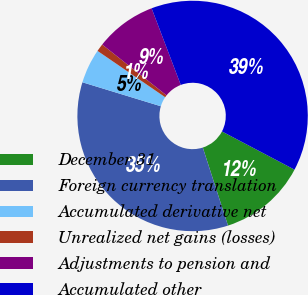Convert chart. <chart><loc_0><loc_0><loc_500><loc_500><pie_chart><fcel>December 31<fcel>Foreign currency translation<fcel>Accumulated derivative net<fcel>Unrealized net gains (losses)<fcel>Adjustments to pension and<fcel>Accumulated other<nl><fcel>12.31%<fcel>34.69%<fcel>4.83%<fcel>1.09%<fcel>8.57%<fcel>38.5%<nl></chart> 